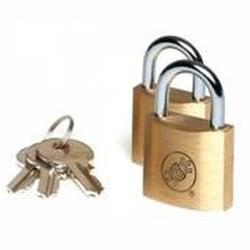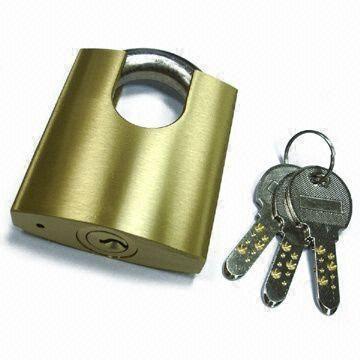The first image is the image on the left, the second image is the image on the right. Assess this claim about the two images: "The right image contains a lock with at least two keys.". Correct or not? Answer yes or no. Yes. 